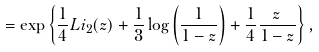<formula> <loc_0><loc_0><loc_500><loc_500>= \exp \left \{ \frac { 1 } { 4 } L i _ { 2 } ( z ) + \frac { 1 } { 3 } \log \left ( \frac { 1 } { 1 - z } \right ) + \frac { 1 } { 4 } \frac { z } { 1 - z } \right \} ,</formula> 